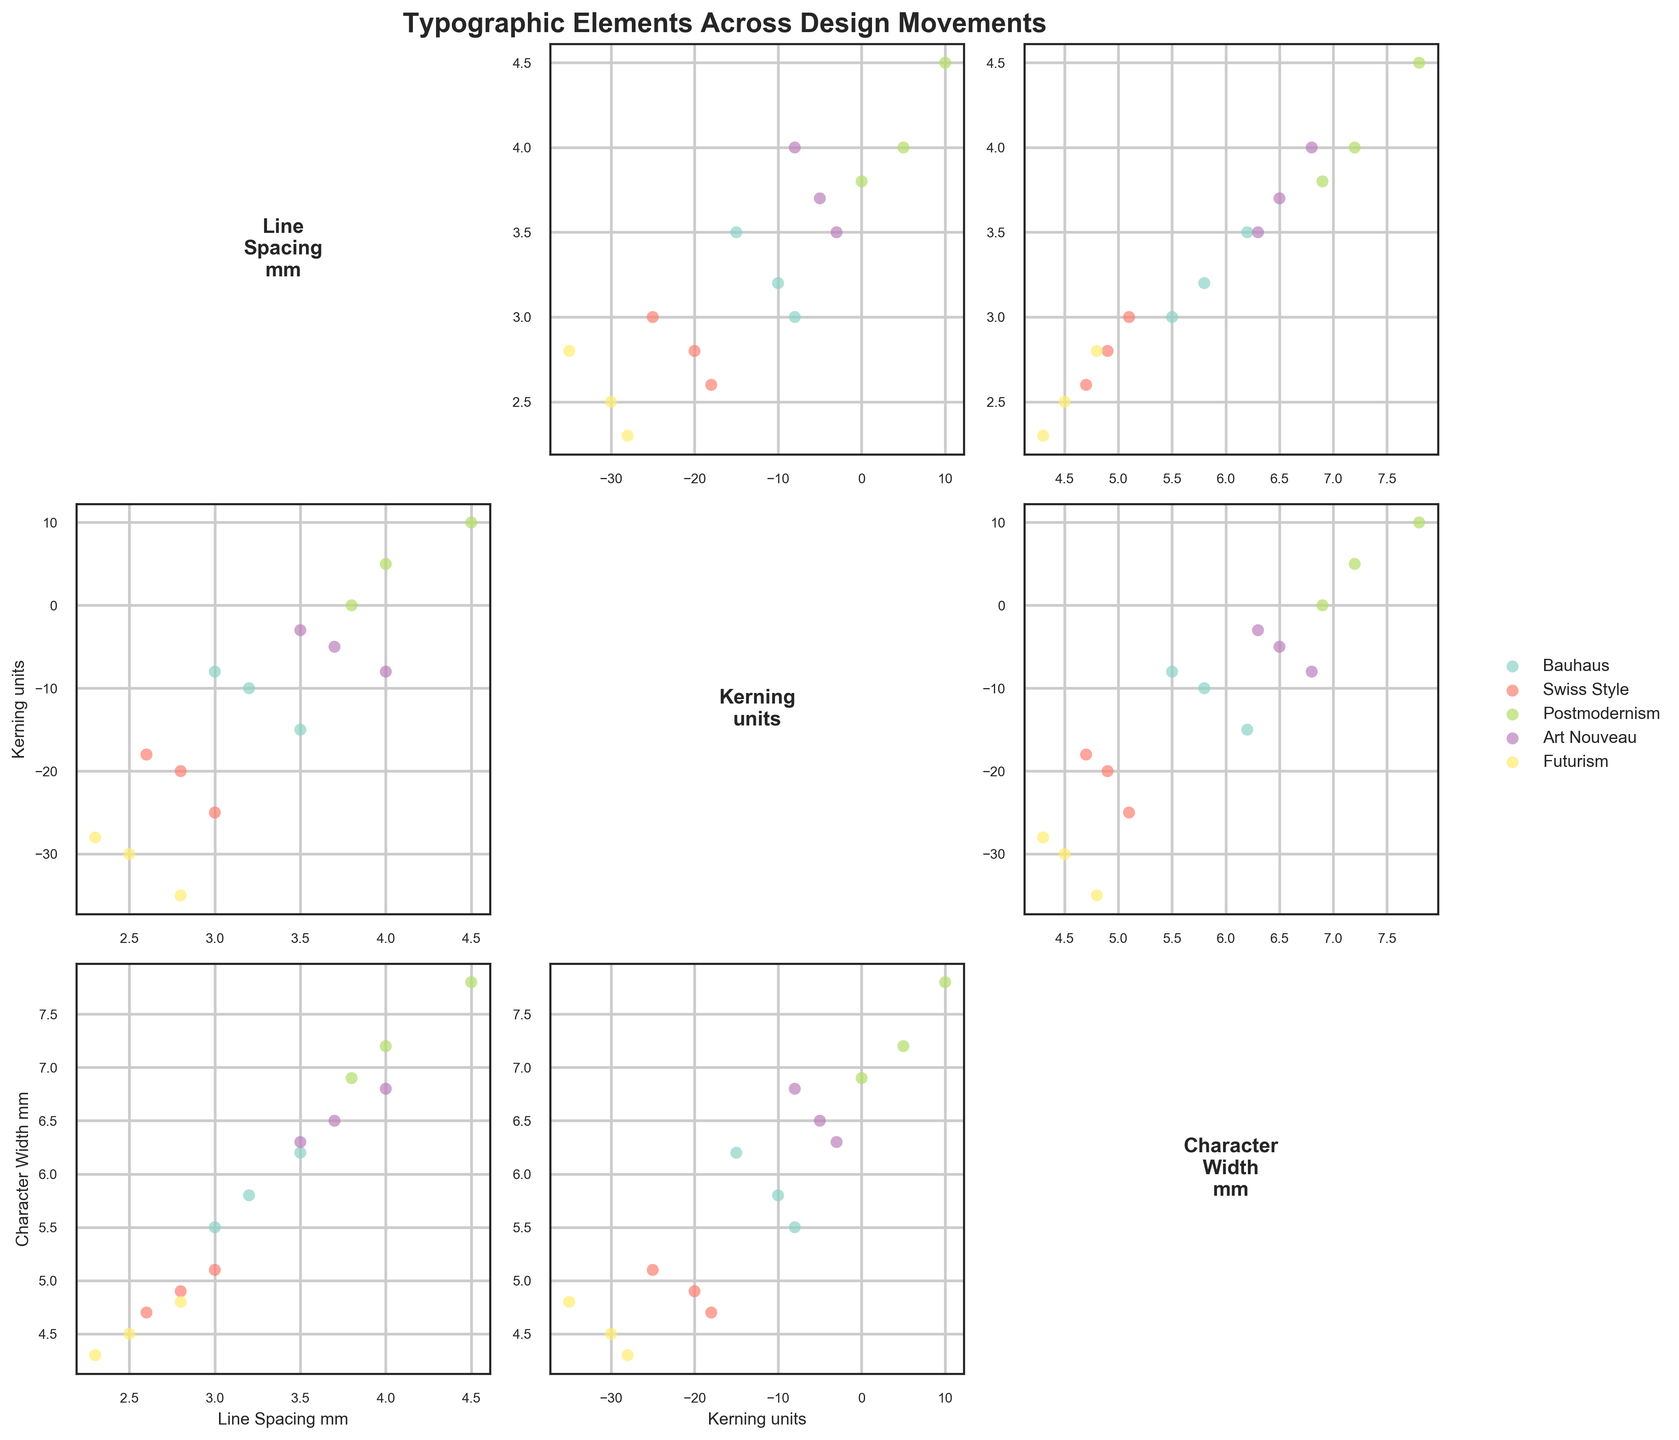What is the title of the scatterplot matrix? The title is usually found at the top of the figure and gives a summary of what the graph represents. In this case, it would be displayed clearly above the scatterplot matrix.
Answer: Typographic Elements Across Design Movements How many different design movements are compared in the scatterplot matrix? We can count the unique colors or labels in the legend as they each represent a different design movement.
Answer: 5 Which data points correspond to the Swiss Style movement in the "Kerning_units" vs "Line_Spacing_mm" plot? To identify these data points, look for the color associated with Swiss Style in the legend, then find those points in the scatterplot comparing "Kerning_units" and "Line_Spacing_mm".
Answer: (2.8, -20), (3.0, -25), (2.6, -18) Which design movement generally has the highest line spacing? By observing the scatterplots, we can see which design movement's data points are positioned higher along the line spacing axis.
Answer: Postmodernism Do any design movements show a positive correlation between kerning and character width? To determine this, look at the scatterplots that plot kerning against character width for each design movement. Check if the data points form an upward trend from left to right.
Answer: Postmodernism What is the range of character widths for the Futurism design movement? By looking at the scatterplots displaying character width for Futurism, we find the minimum and maximum values of this variable.
Answer: 4.3 to 4.8 Compare the line spacing between Bauhaus and Art Nouveau movements. Which one tends to have a higher line spacing? To compare, look at the scatterplots that show line spacing for both movements and see which one has higher values overall.
Answer: Art Nouveau What is the average kerning for Art Nouveau? First, find the kerning values for Art Nouveau, then calculate the average by summing them up and dividing by the number of points.
Answer: (-5 + -8 + -3)/3 = -5.33 Which design movement exhibits the greatest variation in character width? By comparing the range (difference between maximum and minimum) of character widths across all movements, we can see which one has the greatest spread.
Answer: Postmodernism 